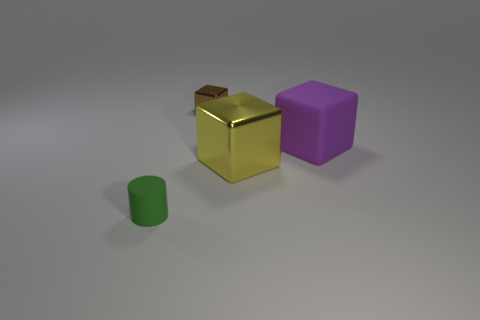The purple block is what size?
Your answer should be compact. Large. What number of small metal things are in front of the tiny cylinder?
Provide a short and direct response. 0. There is another object that is the same material as the purple object; what is its shape?
Provide a succinct answer. Cylinder. Are there fewer small rubber cylinders that are in front of the small matte thing than blocks left of the large yellow shiny thing?
Offer a very short reply. Yes. Are there more small yellow matte cylinders than small brown cubes?
Provide a succinct answer. No. What material is the large yellow thing?
Your answer should be very brief. Metal. What color is the tiny thing that is to the left of the brown block?
Provide a succinct answer. Green. Are there more tiny brown blocks that are to the right of the tiny brown thing than cylinders in front of the tiny matte object?
Ensure brevity in your answer.  No. How big is the object on the left side of the shiny cube that is to the left of the metal cube that is in front of the tiny brown metal block?
Keep it short and to the point. Small. Is there a thing that has the same color as the tiny block?
Offer a very short reply. No. 